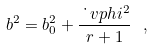<formula> <loc_0><loc_0><loc_500><loc_500>b ^ { 2 } = b _ { 0 } ^ { 2 } + \frac { \dot { \ } v p h i ^ { 2 } } { r + 1 } \ ,</formula> 